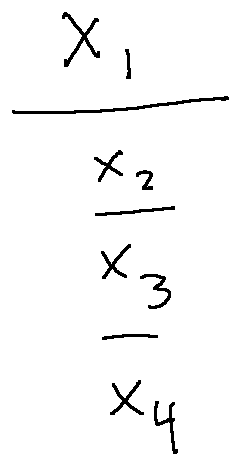<formula> <loc_0><loc_0><loc_500><loc_500>\frac { x _ { 1 } } { \frac { x _ { 2 } } { \frac { x _ { 3 } } { x _ { 4 } } } }</formula> 